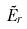Convert formula to latex. <formula><loc_0><loc_0><loc_500><loc_500>\tilde { E } _ { r }</formula> 